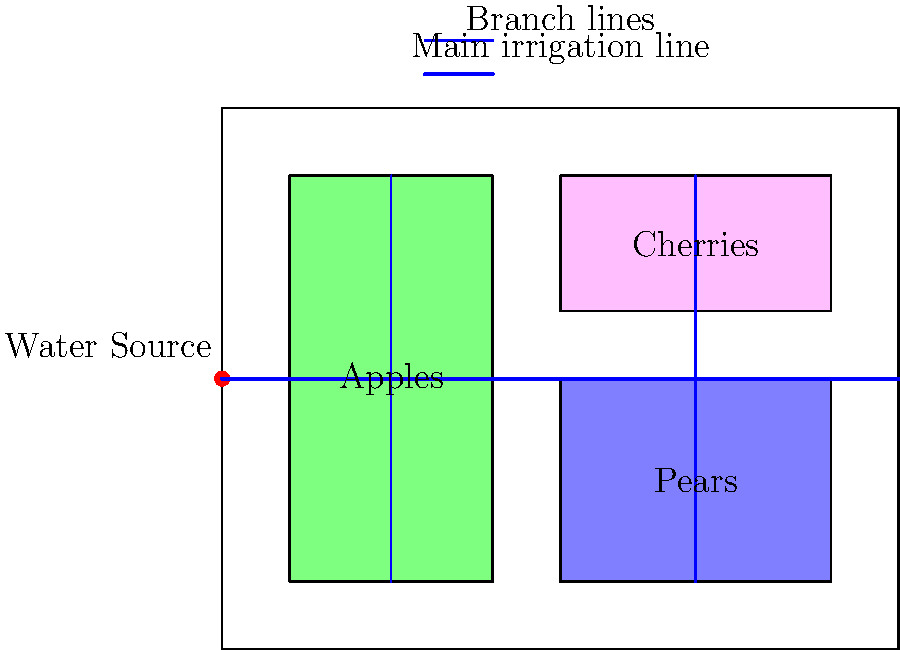Based on the farm plot plan shown, which irrigation system layout would be most efficient for watering the different fruit tree varieties while minimizing water usage and ensuring even distribution? To design an efficient irrigation system for this farm, we need to consider several factors:

1. Water source location: The water source is located on the left side of the farm at the midpoint.

2. Farm layout: The farm is divided into three sections - apples, pears, and cherries.

3. Efficient water distribution: We want to minimize water usage while ensuring even distribution.

4. Topography: Although not shown, we assume the land is relatively flat for simplicity.

The most efficient irrigation system layout would be:

1. Main irrigation line:
   - Run a main irrigation line from the water source horizontally across the farm.
   - This allows for efficient water distribution to all sections.

2. Branch lines:
   - Install vertical branch lines from the main line into each fruit tree section.
   - Two branch lines for apples (one up, one down).
   - Two branch lines for pears and cherries combined (one up, one down).

3. Drip irrigation:
   - Use drip irrigation along the branch lines for precise water delivery to each tree.
   - This minimizes water waste and ensures even distribution.

4. Control valves:
   - Install control valves at the beginning of each branch line.
   - This allows for separate watering schedules for different fruit varieties.

5. Pressure regulators:
   - Install pressure regulators to maintain consistent water pressure throughout the system.

6. Filtration system:
   - Add a filtration system near the water source to prevent clogging in the drip emitters.

This layout ensures efficient water use by:
- Minimizing the total length of piping required.
- Allowing for precise control of water distribution to each section.
- Enabling different watering schedules for each fruit variety based on their specific needs.
- Reducing water loss through evaporation by using drip irrigation.
Answer: Main horizontal line with vertical branches and drip irrigation 